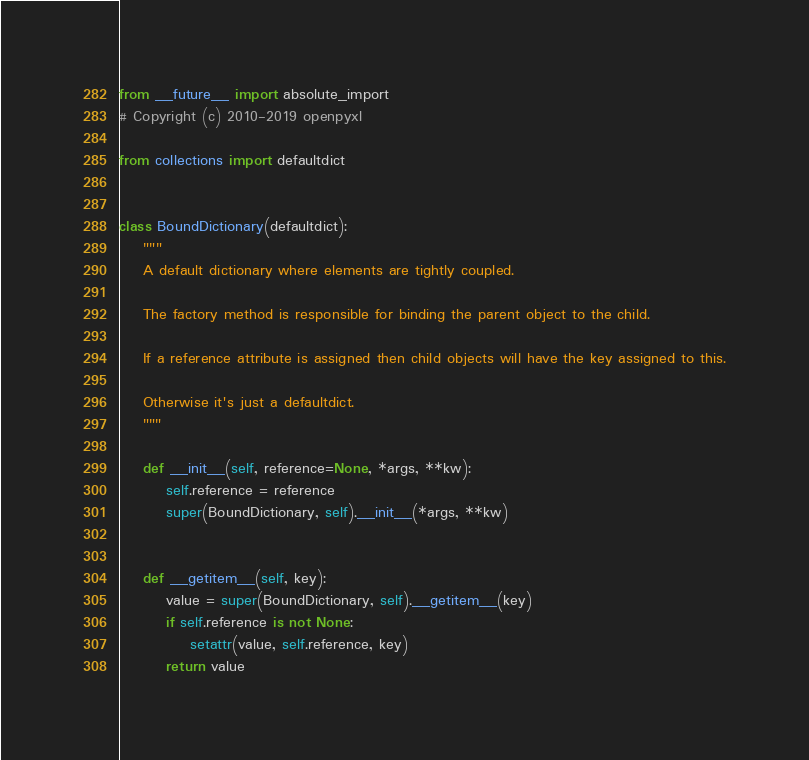Convert code to text. <code><loc_0><loc_0><loc_500><loc_500><_Python_>from __future__ import absolute_import
# Copyright (c) 2010-2019 openpyxl

from collections import defaultdict


class BoundDictionary(defaultdict):
    """
    A default dictionary where elements are tightly coupled.

    The factory method is responsible for binding the parent object to the child.

    If a reference attribute is assigned then child objects will have the key assigned to this.

    Otherwise it's just a defaultdict.
    """

    def __init__(self, reference=None, *args, **kw):
        self.reference = reference
        super(BoundDictionary, self).__init__(*args, **kw)


    def __getitem__(self, key):
        value = super(BoundDictionary, self).__getitem__(key)
        if self.reference is not None:
            setattr(value, self.reference, key)
        return value
</code> 